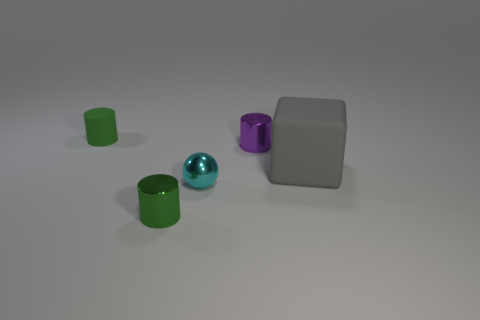Add 4 big cyan shiny blocks. How many objects exist? 9 Subtract all blocks. How many objects are left? 4 Subtract all green matte cylinders. Subtract all big brown spheres. How many objects are left? 4 Add 5 cyan metallic objects. How many cyan metallic objects are left? 6 Add 3 cyan metallic spheres. How many cyan metallic spheres exist? 4 Subtract 2 green cylinders. How many objects are left? 3 